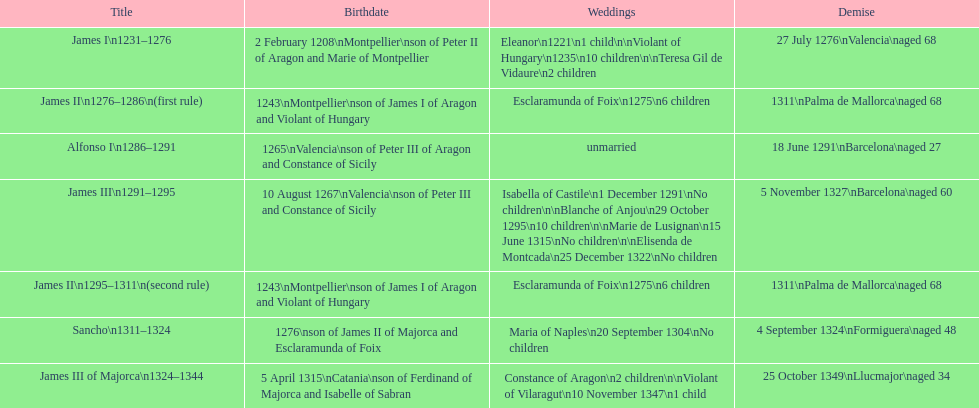How many of these monarchs died before the age of 65? 4. 